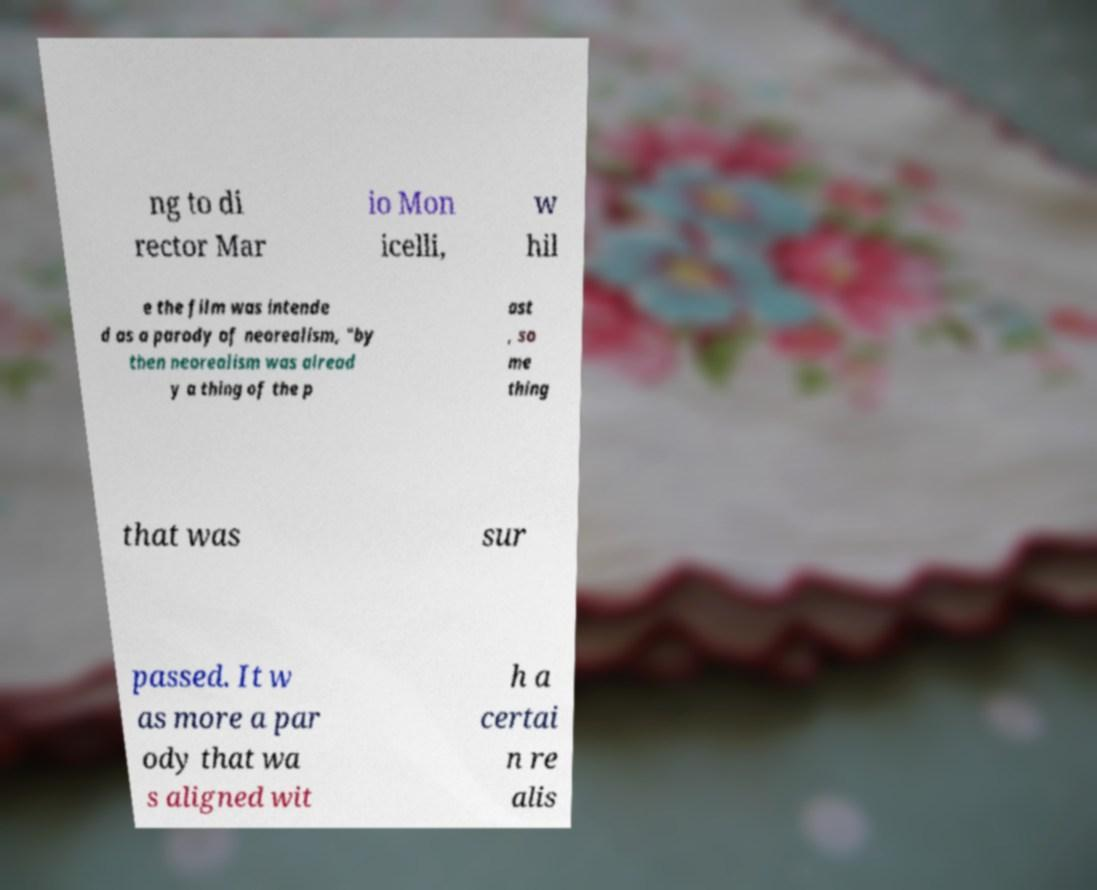I need the written content from this picture converted into text. Can you do that? ng to di rector Mar io Mon icelli, w hil e the film was intende d as a parody of neorealism, "by then neorealism was alread y a thing of the p ast , so me thing that was sur passed. It w as more a par ody that wa s aligned wit h a certai n re alis 